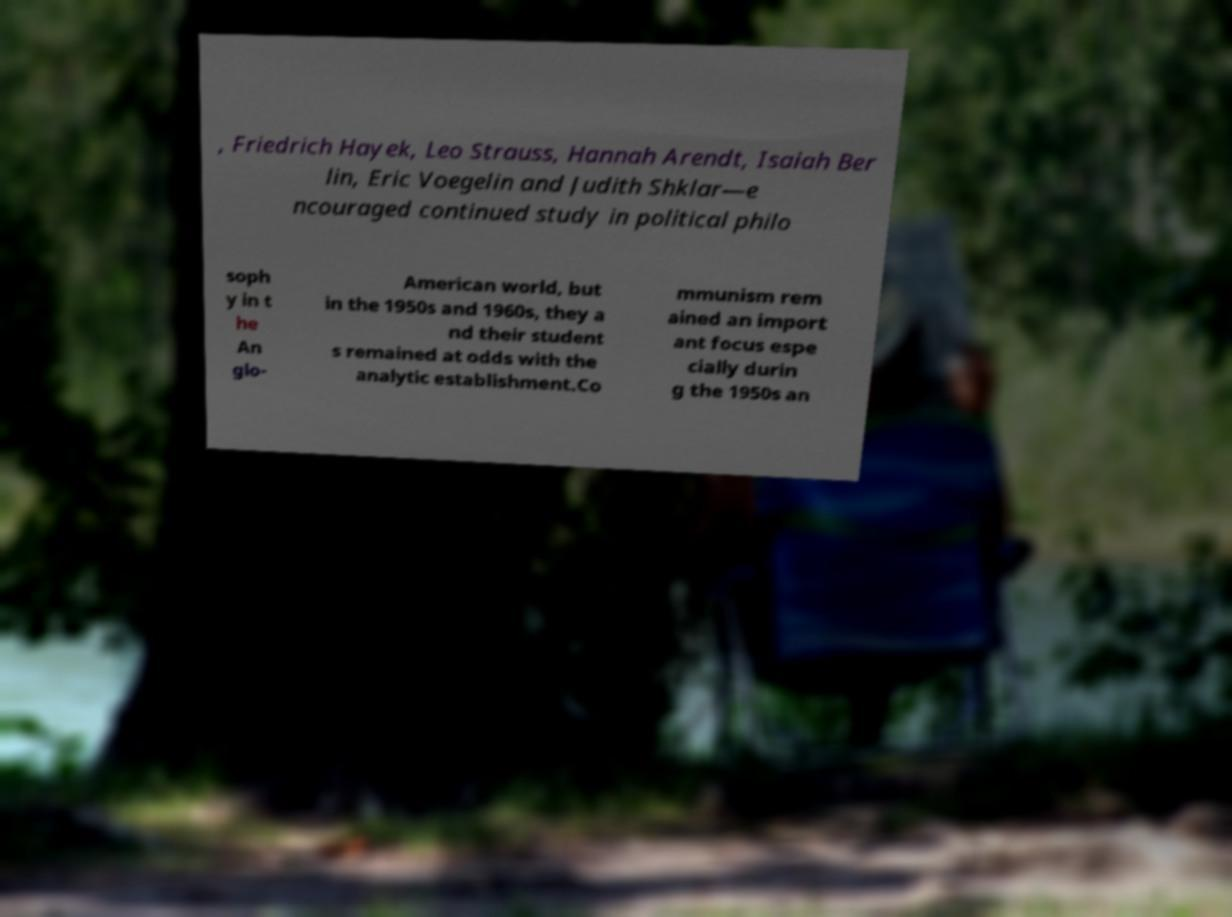For documentation purposes, I need the text within this image transcribed. Could you provide that? , Friedrich Hayek, Leo Strauss, Hannah Arendt, Isaiah Ber lin, Eric Voegelin and Judith Shklar—e ncouraged continued study in political philo soph y in t he An glo- American world, but in the 1950s and 1960s, they a nd their student s remained at odds with the analytic establishment.Co mmunism rem ained an import ant focus espe cially durin g the 1950s an 